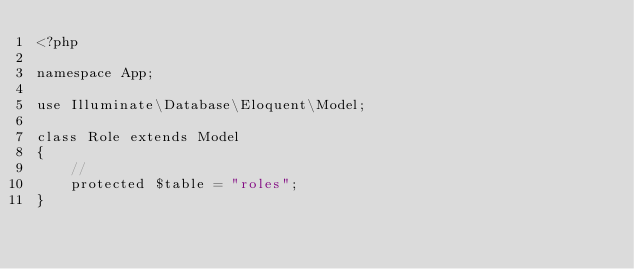<code> <loc_0><loc_0><loc_500><loc_500><_PHP_><?php

namespace App;

use Illuminate\Database\Eloquent\Model;

class Role extends Model
{
    //
    protected $table = "roles";
}
</code> 